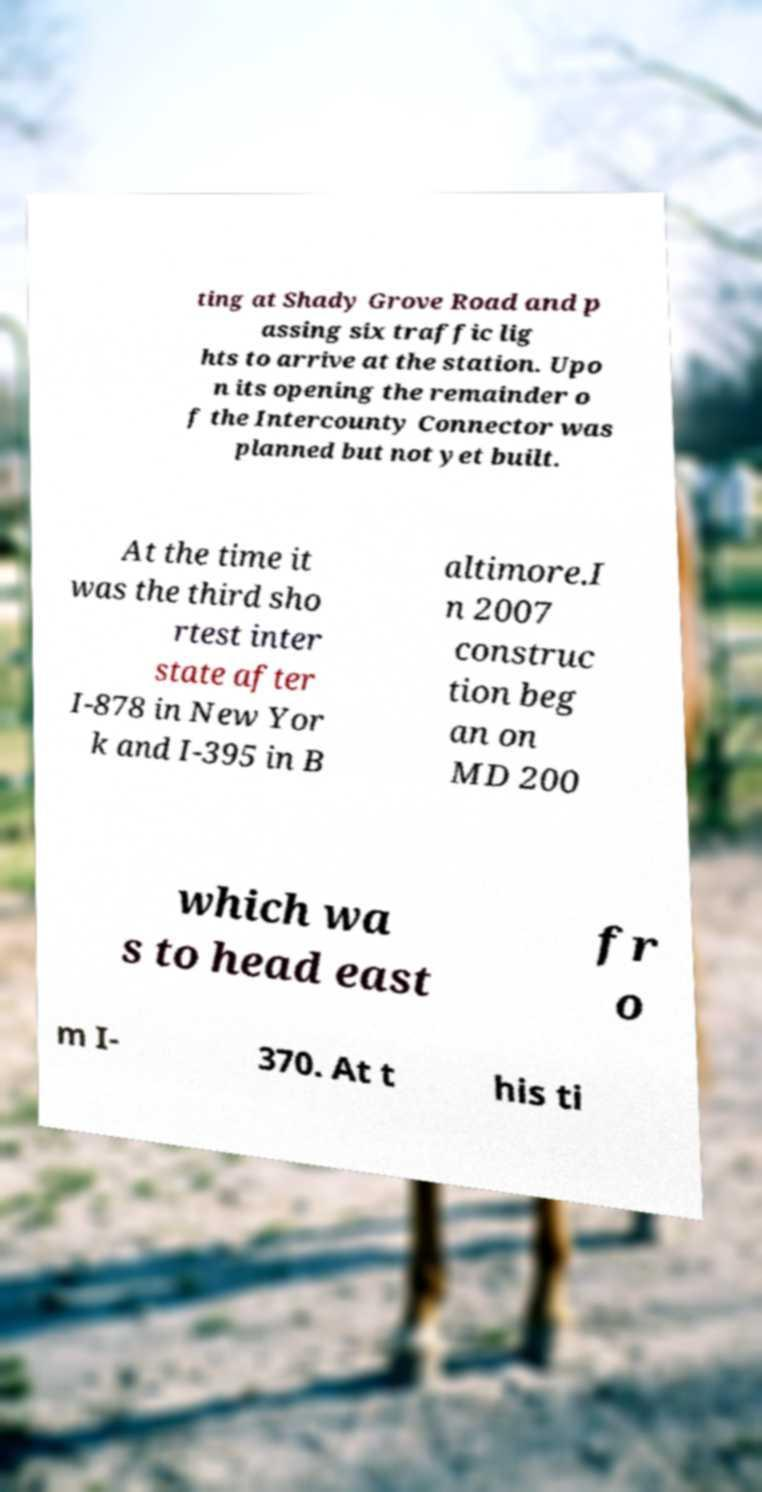What messages or text are displayed in this image? I need them in a readable, typed format. ting at Shady Grove Road and p assing six traffic lig hts to arrive at the station. Upo n its opening the remainder o f the Intercounty Connector was planned but not yet built. At the time it was the third sho rtest inter state after I-878 in New Yor k and I-395 in B altimore.I n 2007 construc tion beg an on MD 200 which wa s to head east fr o m I- 370. At t his ti 